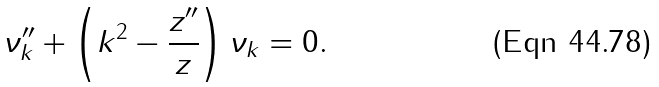Convert formula to latex. <formula><loc_0><loc_0><loc_500><loc_500>\nu _ { k } ^ { \prime \prime } + \left ( k ^ { 2 } - \frac { z ^ { \prime \prime } } { z } \right ) \nu _ { k } = 0 .</formula> 